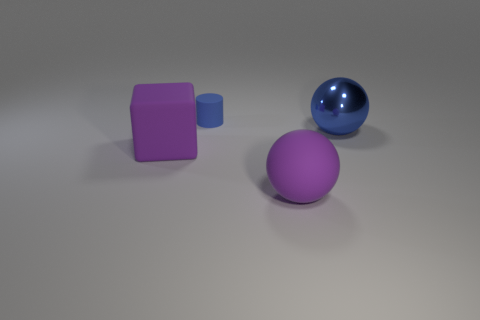Subtract all cylinders. How many objects are left? 3 Add 2 small yellow matte things. How many objects exist? 6 Add 2 large matte objects. How many large matte objects exist? 4 Subtract 1 purple blocks. How many objects are left? 3 Subtract all large purple rubber spheres. Subtract all metallic cylinders. How many objects are left? 3 Add 3 purple rubber blocks. How many purple rubber blocks are left? 4 